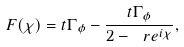Convert formula to latex. <formula><loc_0><loc_0><loc_500><loc_500>F ( \chi ) = t \Gamma _ { \phi } - \frac { t \Gamma _ { \phi } } { 2 - \ r e ^ { i \chi } } ,</formula> 